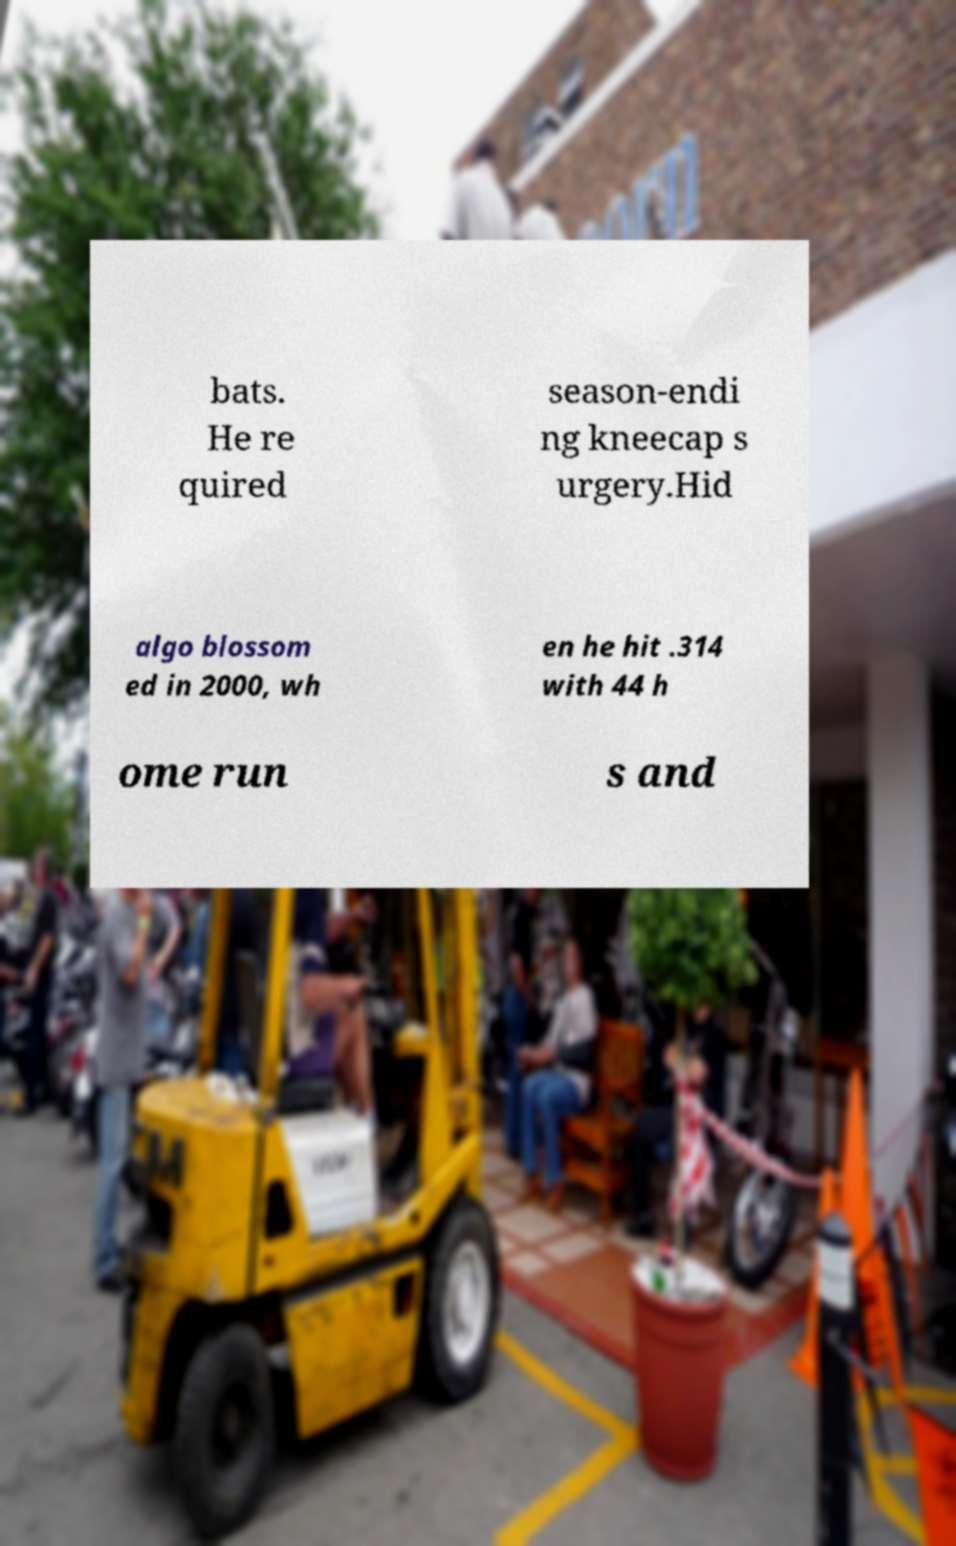Can you accurately transcribe the text from the provided image for me? bats. He re quired season-endi ng kneecap s urgery.Hid algo blossom ed in 2000, wh en he hit .314 with 44 h ome run s and 